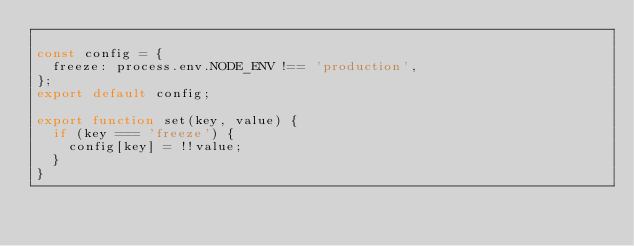<code> <loc_0><loc_0><loc_500><loc_500><_JavaScript_>
const config = {
  freeze: process.env.NODE_ENV !== 'production',
};
export default config;

export function set(key, value) {
  if (key === 'freeze') {
    config[key] = !!value;
  }
}
</code> 